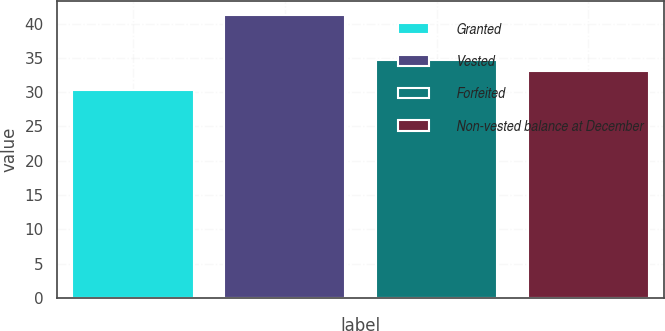Convert chart to OTSL. <chart><loc_0><loc_0><loc_500><loc_500><bar_chart><fcel>Granted<fcel>Vested<fcel>Forfeited<fcel>Non-vested balance at December<nl><fcel>30.3<fcel>41.23<fcel>34.72<fcel>33.14<nl></chart> 